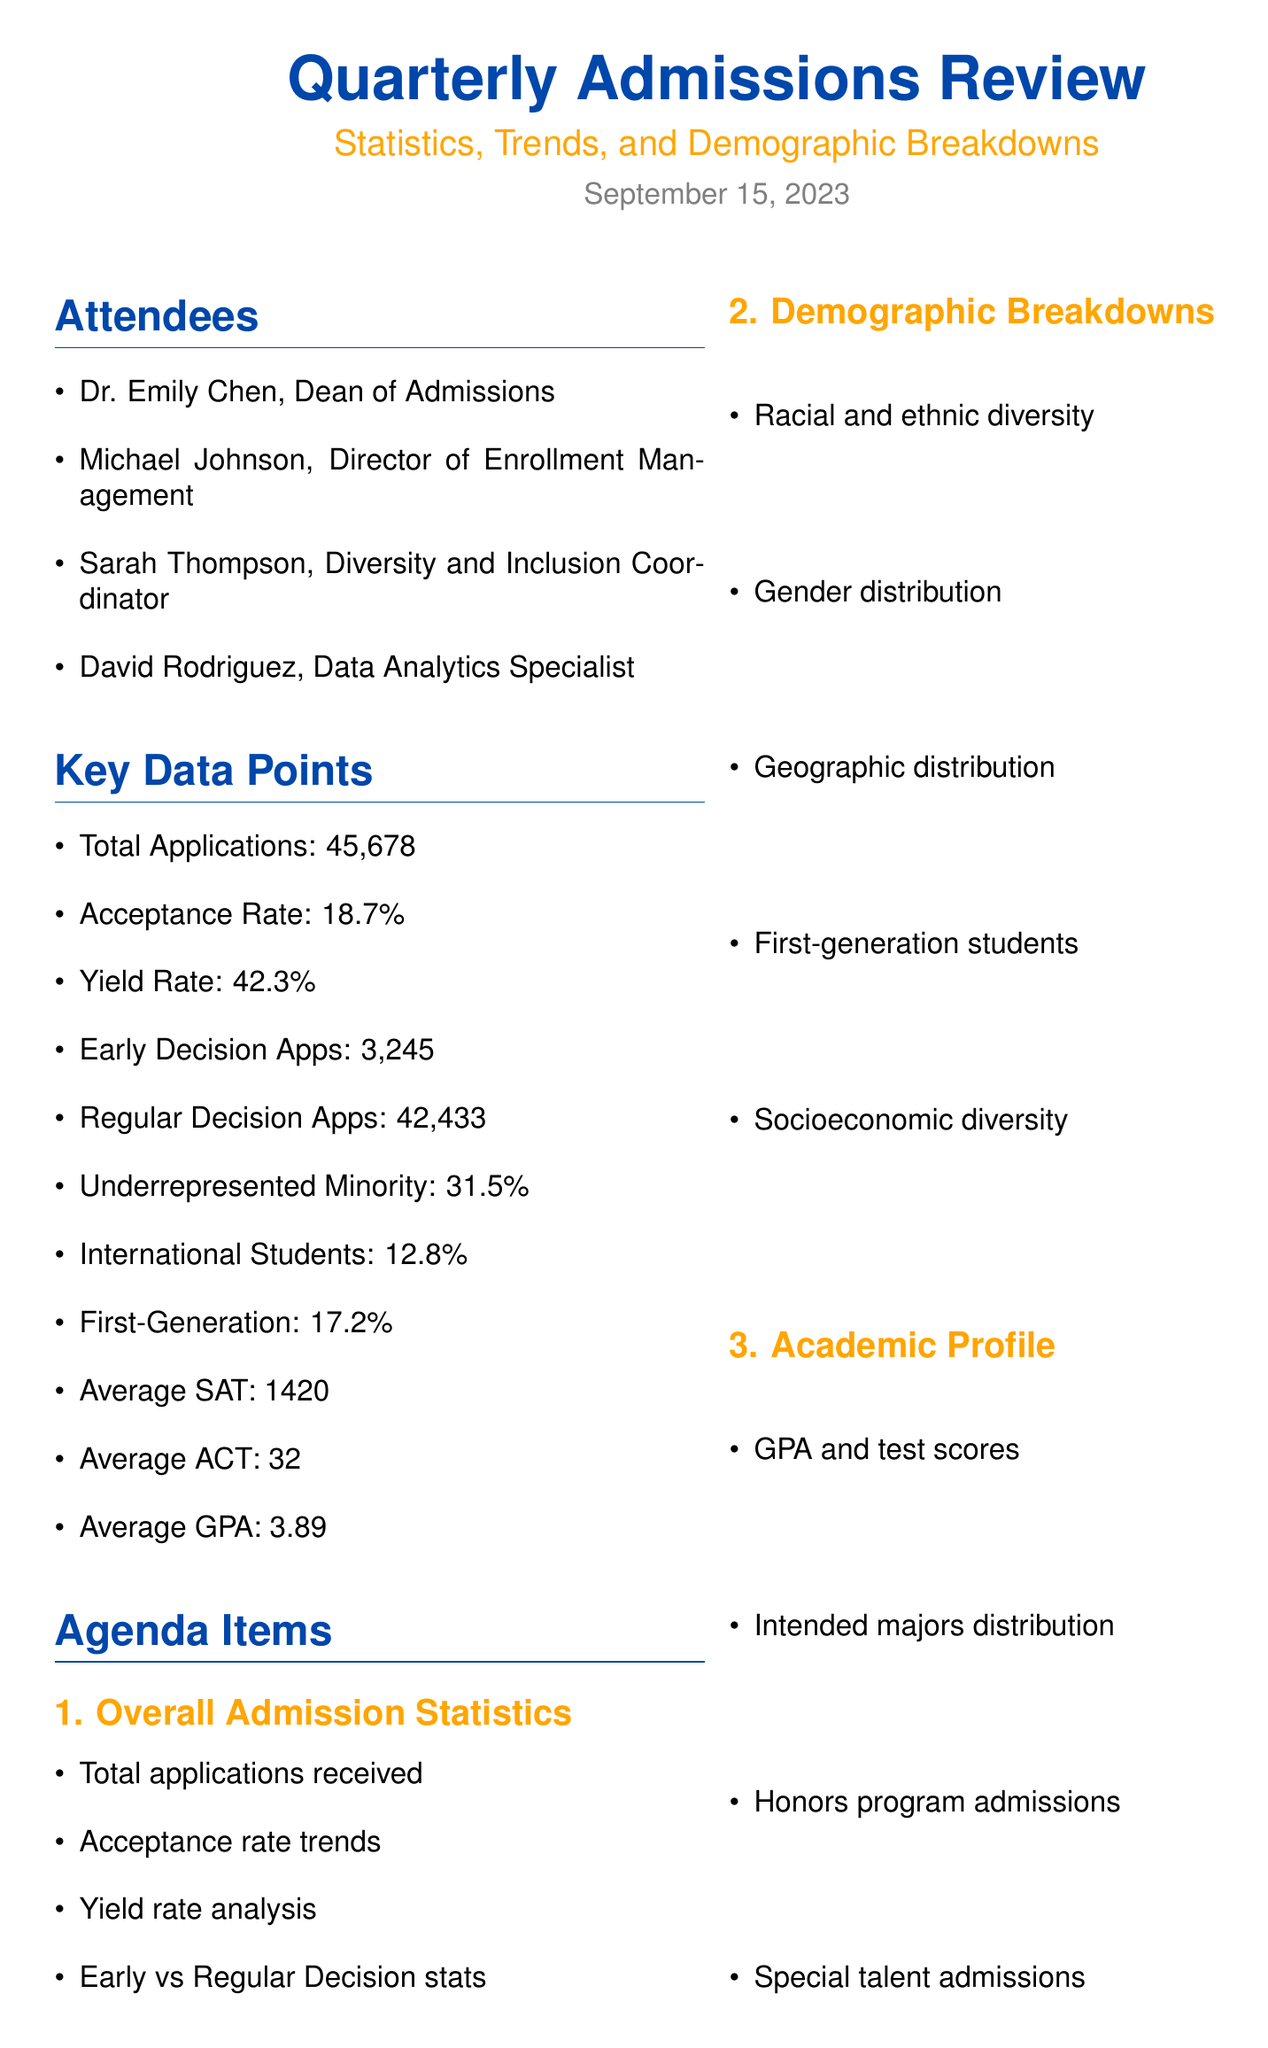what is the total number of applications received? The total number of applications received is specified in the key data points section of the document.
Answer: 45,678 what is the acceptance rate? The acceptance rate is listed among the key data points in the document.
Answer: 18.7% what percentage of students are first-generation college students? This percentage is provided in the key data points section of the document.
Answer: 17.2% how many attendees are listed for the meeting? The number of attendees is mentioned in the attendees section of the document.
Answer: 4 what are the average SAT scores of admitted students? The average SAT score is stated in the key data points of the document.
Answer: 1420 which agenda item focuses on financial aid allocation? The agenda items section of the document includes several topics; one directly relates to financial aid.
Answer: Financial Aid and Scholarships what is one emerging trend in admissions mentioned? Emerging trends are discussed in a specific agenda section and provide valuable insights into current issues.
Answer: Impact of COVID-19 on admissions what is the goal related to diversity improvement mentioned in the action items? The action items section outlines specific goals for the upcoming admissions cycle, including diversity initiatives.
Answer: Areas for improvement in diversity and inclusion 